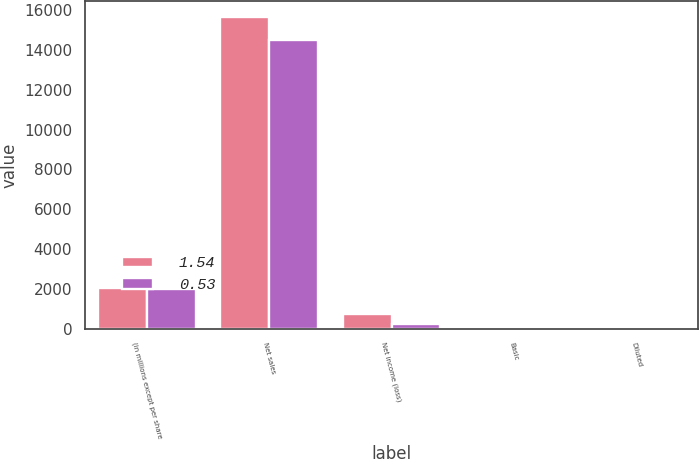<chart> <loc_0><loc_0><loc_500><loc_500><stacked_bar_chart><ecel><fcel>(in millions except per share<fcel>Net sales<fcel>Net income (loss)<fcel>Basic<fcel>Diluted<nl><fcel>1.54<fcel>2016<fcel>15657.6<fcel>748<fcel>1.55<fcel>1.54<nl><fcel>0.53<fcel>2015<fcel>14519.6<fcel>254.9<fcel>0.53<fcel>0.53<nl></chart> 